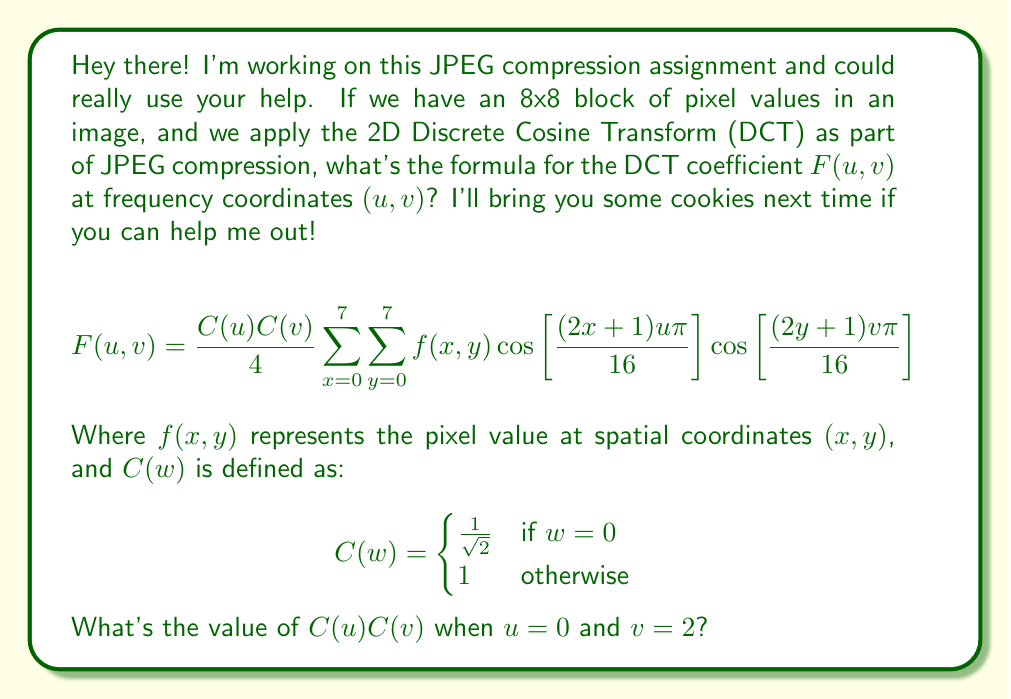Can you solve this math problem? Let's approach this step-by-step:

1) We need to determine the values of $C(u)$ and $C(v)$ separately, then multiply them.

2) For $C(u)$:
   - We're given that $u = 0$
   - From the definition of $C(w)$, when $w = 0$, $C(w) = \frac{1}{\sqrt{2}}$
   - Therefore, $C(u) = C(0) = \frac{1}{\sqrt{2}}$

3) For $C(v)$:
   - We're given that $v = 2$
   - From the definition of $C(w)$, when $w \neq 0$, $C(w) = 1$
   - Therefore, $C(v) = C(2) = 1$

4) Now, we multiply these values:
   $C(u)C(v) = C(0)C(2) = \frac{1}{\sqrt{2}} \cdot 1 = \frac{1}{\sqrt{2}}$

Thus, when $u=0$ and $v=2$, the value of $C(u)C(v)$ is $\frac{1}{\sqrt{2}}$.
Answer: $\frac{1}{\sqrt{2}}$ 